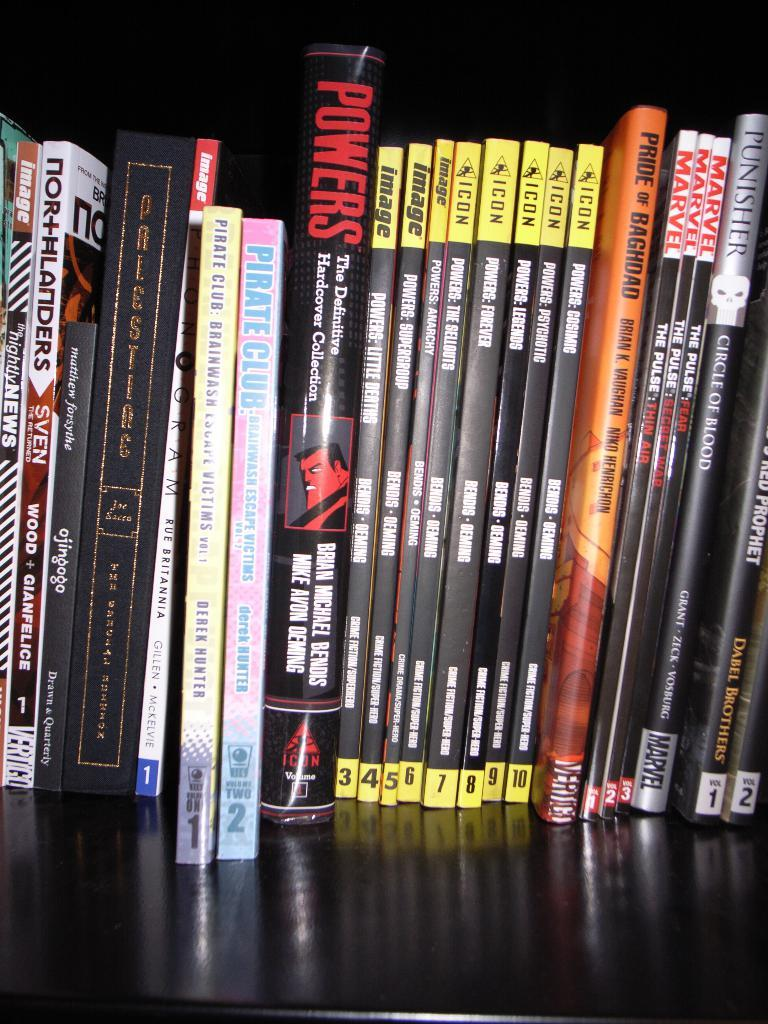Provide a one-sentence caption for the provided image. Several books lined up on a shelf with some named Powers or Marvel. 